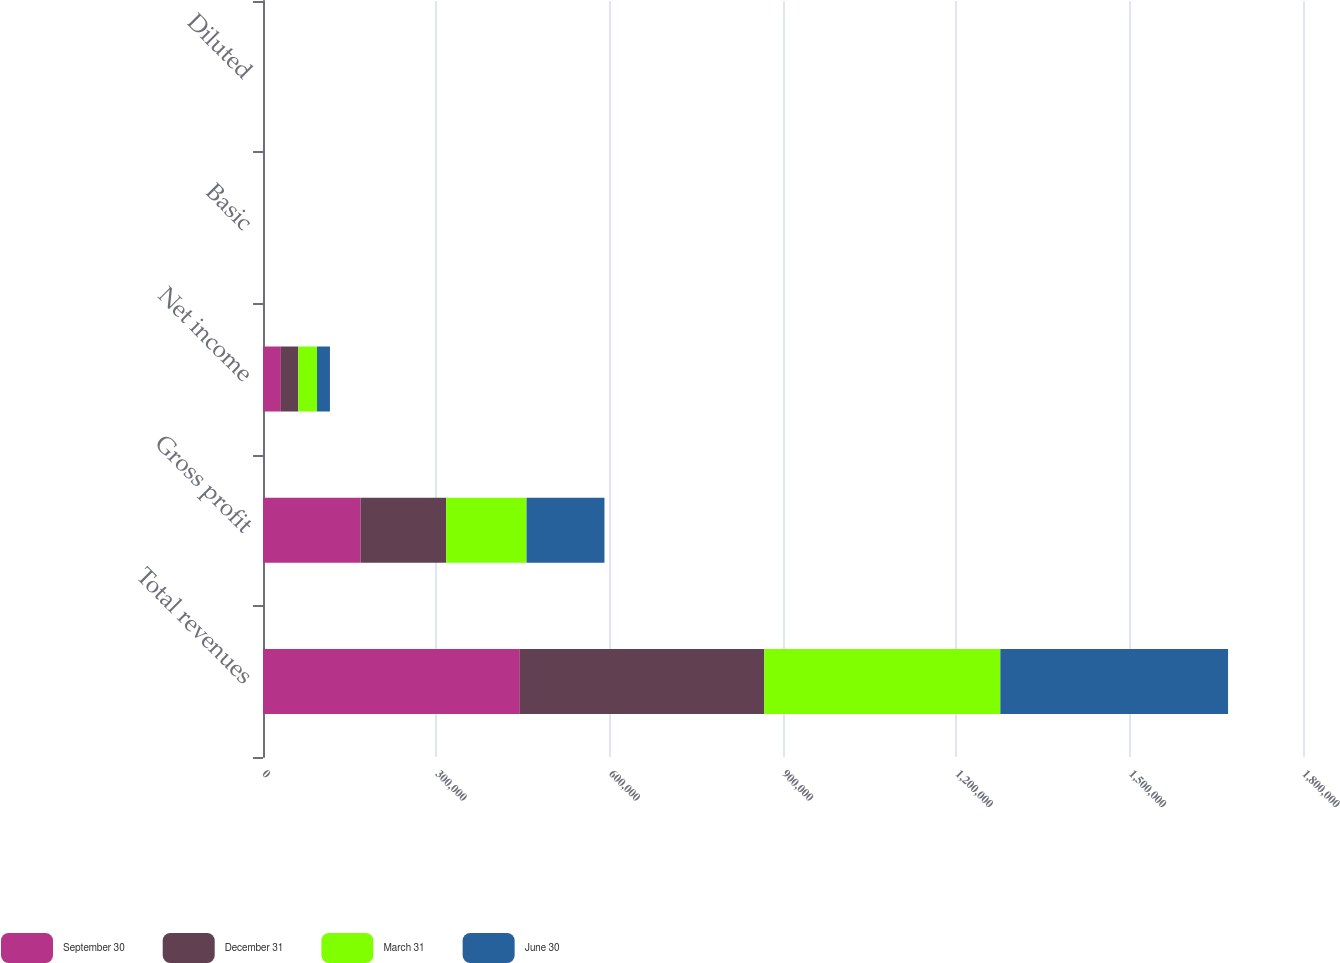Convert chart. <chart><loc_0><loc_0><loc_500><loc_500><stacked_bar_chart><ecel><fcel>Total revenues<fcel>Gross profit<fcel>Net income<fcel>Basic<fcel>Diluted<nl><fcel>September 30<fcel>444542<fcel>169056<fcel>30913<fcel>0.58<fcel>0.56<nl><fcel>December 31<fcel>423120<fcel>147846<fcel>30141<fcel>0.54<fcel>0.52<nl><fcel>March 31<fcel>408509<fcel>139266<fcel>32443<fcel>0.56<fcel>0.54<nl><fcel>June 30<fcel>394098<fcel>134830<fcel>22363<fcel>0.38<fcel>0.37<nl></chart> 